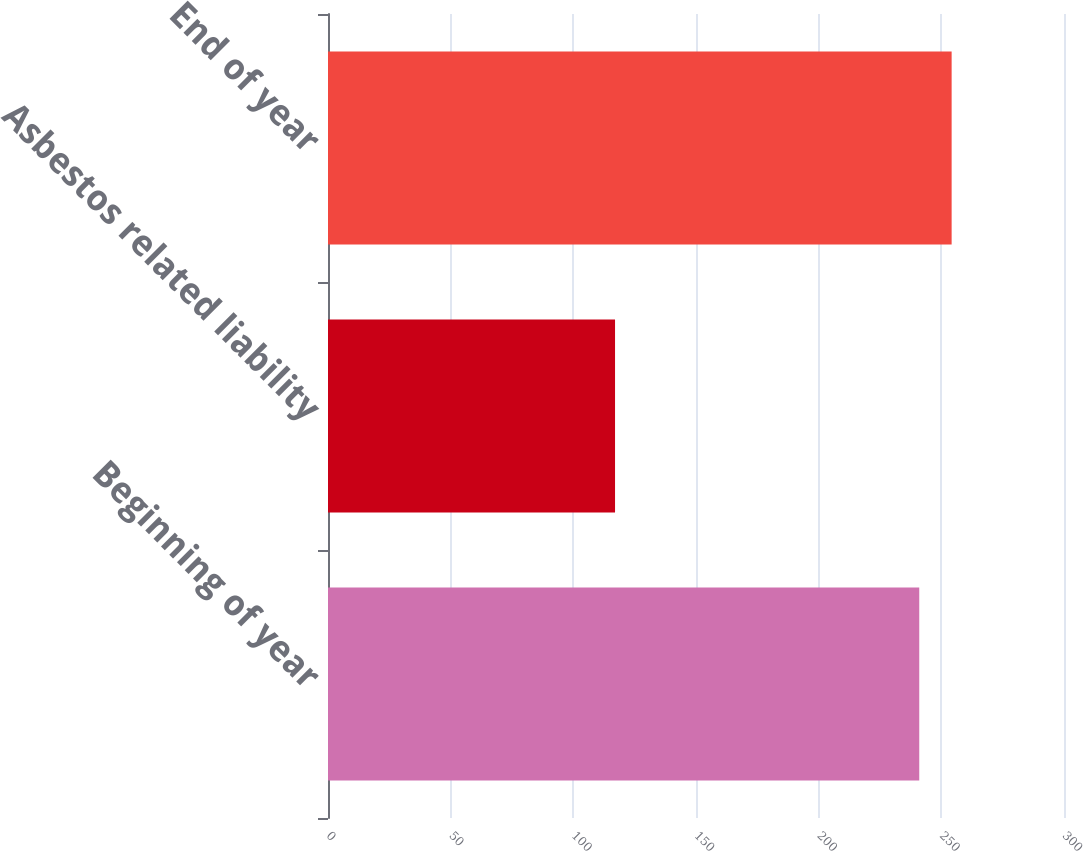Convert chart to OTSL. <chart><loc_0><loc_0><loc_500><loc_500><bar_chart><fcel>Beginning of year<fcel>Asbestos related liability<fcel>End of year<nl><fcel>241<fcel>117<fcel>254.2<nl></chart> 